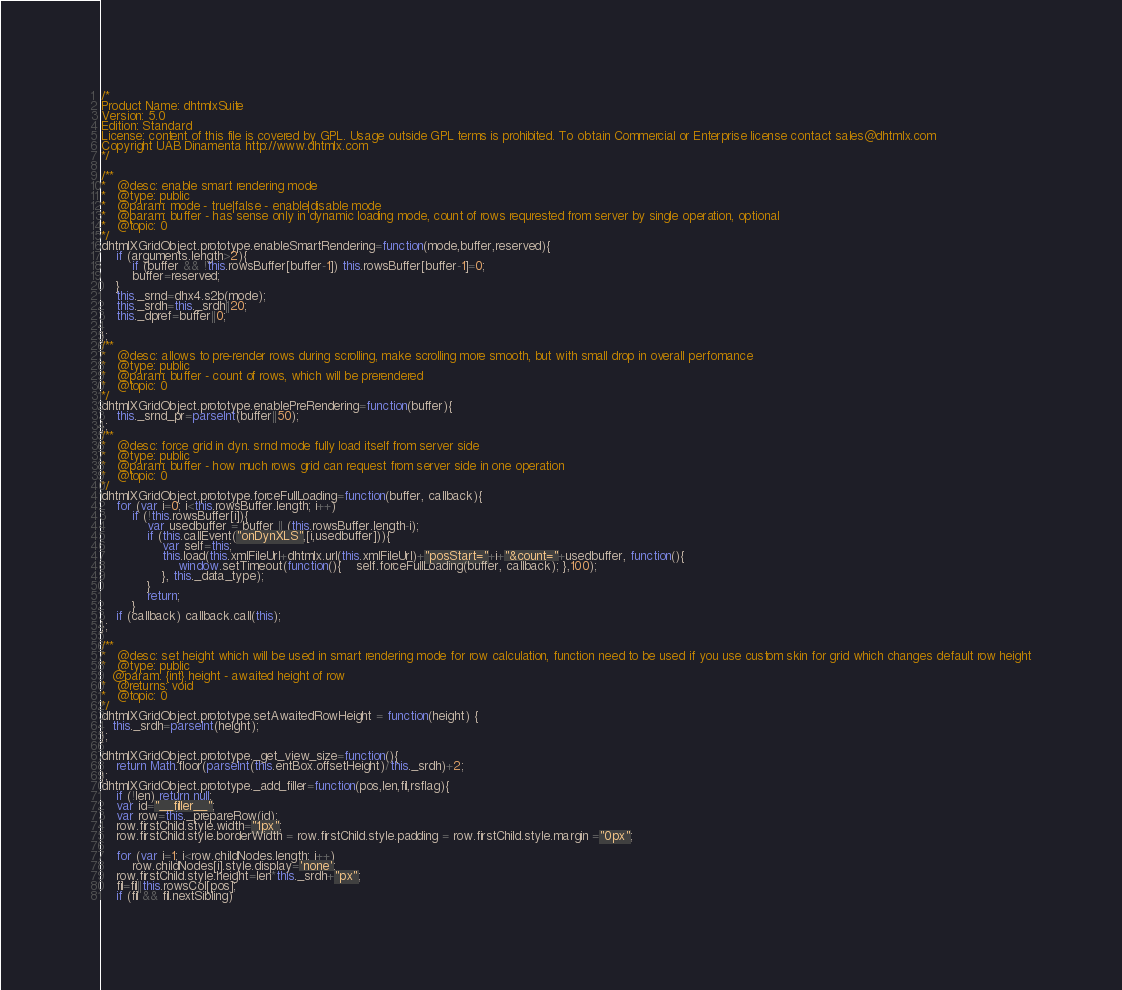Convert code to text. <code><loc_0><loc_0><loc_500><loc_500><_JavaScript_>/*
Product Name: dhtmlxSuite 
Version: 5.0 
Edition: Standard 
License: content of this file is covered by GPL. Usage outside GPL terms is prohibited. To obtain Commercial or Enterprise license contact sales@dhtmlx.com
Copyright UAB Dinamenta http://www.dhtmlx.com
*/

/**
*   @desc: enable smart rendering mode
*   @type: public
*   @param: mode - true|false - enable|disable mode
*   @param: buffer - has sense only in dynamic loading mode, count of rows requrested from server by single operation, optional
*   @topic: 0
*/
dhtmlXGridObject.prototype.enableSmartRendering=function(mode,buffer,reserved){
	if (arguments.length>2){
		if (buffer && !this.rowsBuffer[buffer-1]) this.rowsBuffer[buffer-1]=0;
		buffer=reserved;
	}
	this._srnd=dhx4.s2b(mode);
	this._srdh=this._srdh||20;
	this._dpref=buffer||0;
	
};
/**
*   @desc: allows to pre-render rows during scrolling, make scrolling more smooth, but with small drop in overall perfomance
*   @type: public
*   @param: buffer - count of rows, which will be prerendered
*   @topic: 0
*/
dhtmlXGridObject.prototype.enablePreRendering=function(buffer){
	this._srnd_pr=parseInt(buffer||50);
};
/**
*   @desc: force grid in dyn. srnd mode fully load itself from server side
*   @type: public
*   @param: buffer - how much rows grid can request from server side in one operation
*   @topic: 0
*/
dhtmlXGridObject.prototype.forceFullLoading=function(buffer, callback){
	for (var i=0; i<this.rowsBuffer.length; i++)
		if (!this.rowsBuffer[i]){
			var usedbuffer = buffer || (this.rowsBuffer.length-i);
			if (this.callEvent("onDynXLS",[i,usedbuffer])){
				var self=this;
				this.load(this.xmlFileUrl+dhtmlx.url(this.xmlFileUrl)+"posStart="+i+"&count="+usedbuffer, function(){
					window.setTimeout(function(){	self.forceFullLoading(buffer, callback); },100); 
				}, this._data_type);
			}
			return;
		}
	if (callback) callback.call(this);
};

/**
*   @desc: set height which will be used in smart rendering mode for row calculation, function need to be used if you use custom skin for grid which changes default row height
*   @type: public
   @param: {int} height - awaited height of row
*   @returns: void
*   @topic: 0
*/      
dhtmlXGridObject.prototype.setAwaitedRowHeight = function(height) {
   this._srdh=parseInt(height);
};

dhtmlXGridObject.prototype._get_view_size=function(){
	return Math.floor(parseInt(this.entBox.offsetHeight)/this._srdh)+2;
};
dhtmlXGridObject.prototype._add_filler=function(pos,len,fil,rsflag){
	if (!len) return null;
	var id="__filler__";
	var row=this._prepareRow(id);
	row.firstChild.style.width="1px";
	row.firstChild.style.borderWidth = row.firstChild.style.padding = row.firstChild.style.margin ="0px";

	for (var i=1; i<row.childNodes.length; i++)
	    row.childNodes[i].style.display='none';
 	row.firstChild.style.height=len*this._srdh+"px";
 	fil=fil||this.rowsCol[pos];
 	if (fil && fil.nextSibling) </code> 